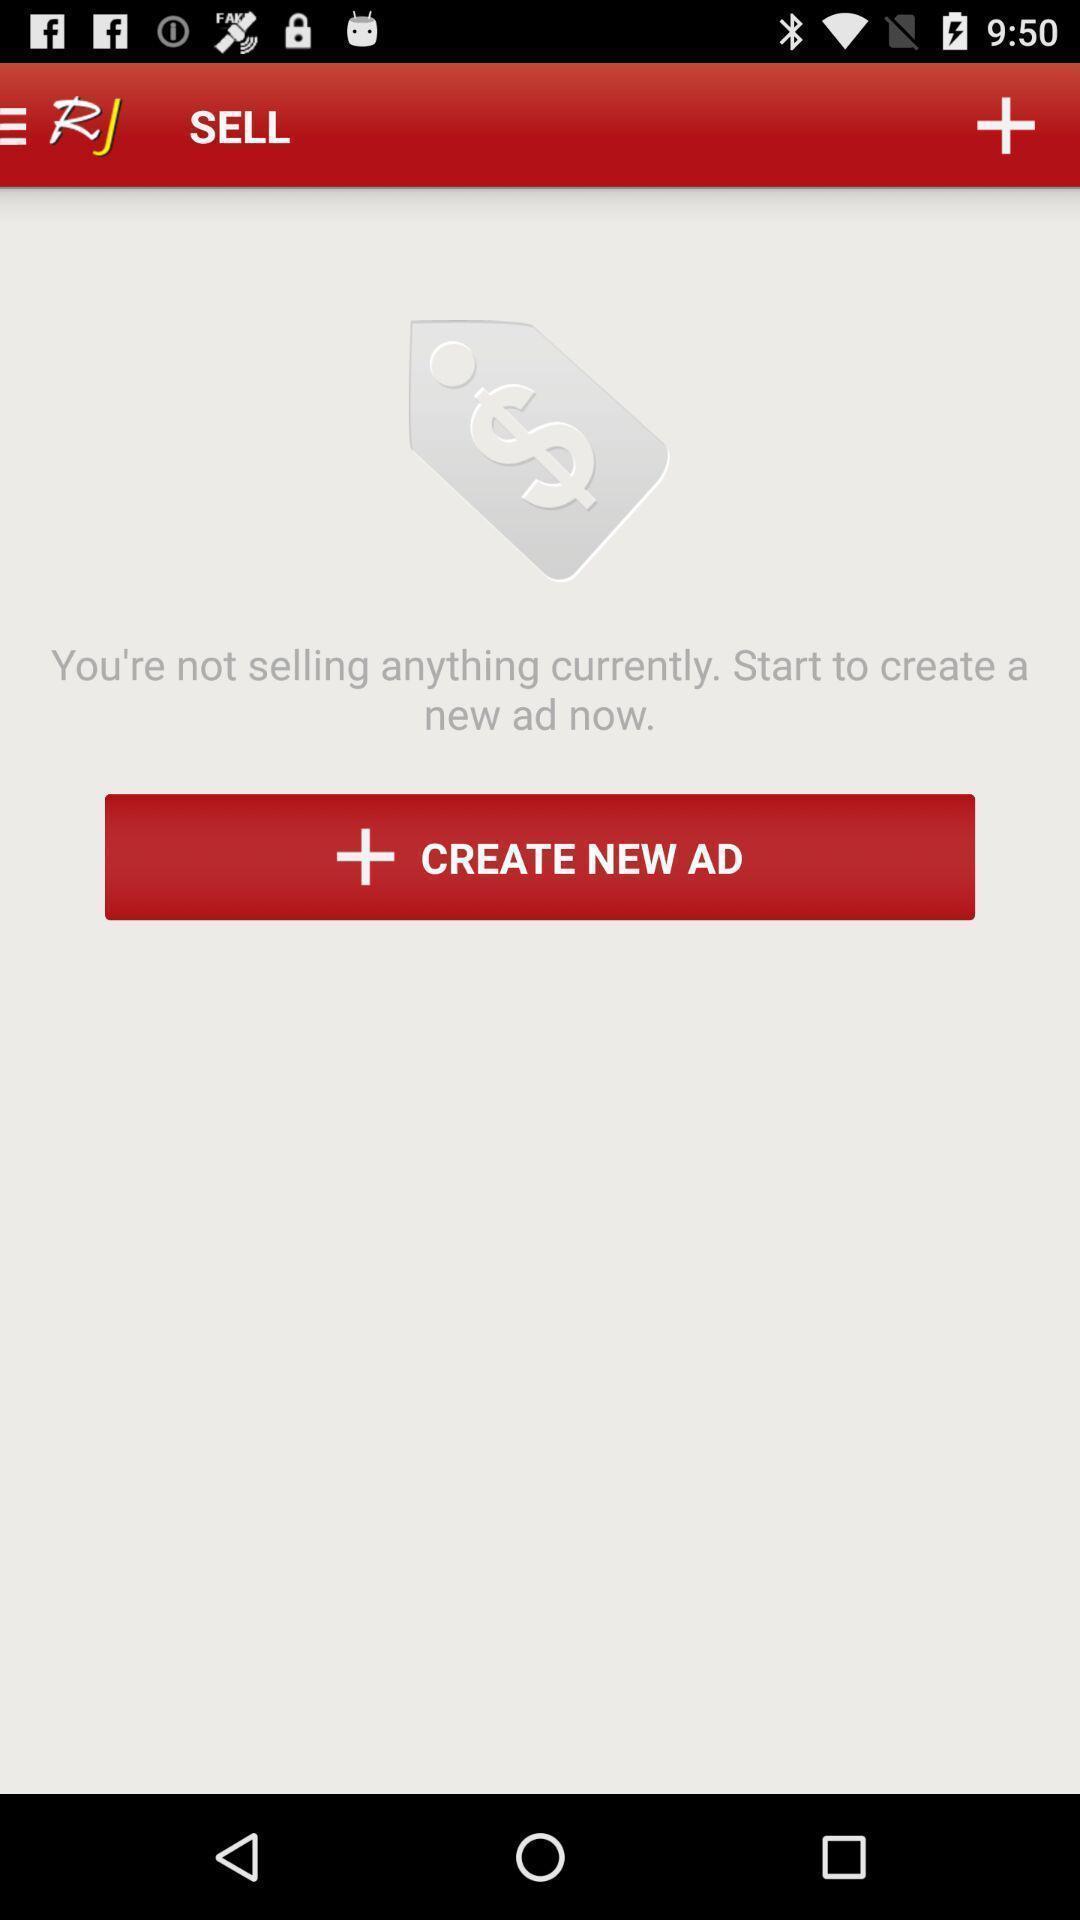Summarize the information in this screenshot. Screen display to create new advertisement option. 